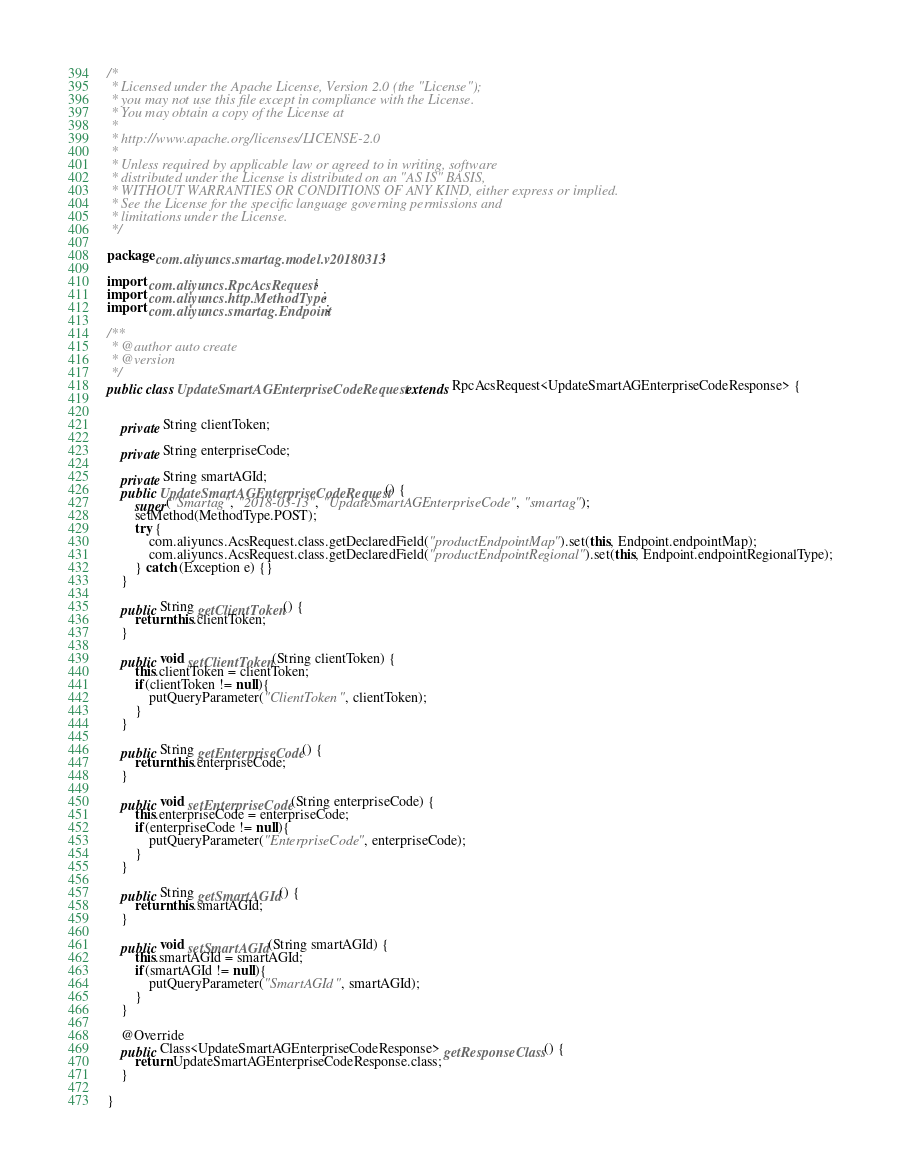<code> <loc_0><loc_0><loc_500><loc_500><_Java_>/*
 * Licensed under the Apache License, Version 2.0 (the "License");
 * you may not use this file except in compliance with the License.
 * You may obtain a copy of the License at
 *
 * http://www.apache.org/licenses/LICENSE-2.0
 *
 * Unless required by applicable law or agreed to in writing, software
 * distributed under the License is distributed on an "AS IS" BASIS,
 * WITHOUT WARRANTIES OR CONDITIONS OF ANY KIND, either express or implied.
 * See the License for the specific language governing permissions and
 * limitations under the License.
 */

package com.aliyuncs.smartag.model.v20180313;

import com.aliyuncs.RpcAcsRequest;
import com.aliyuncs.http.MethodType;
import com.aliyuncs.smartag.Endpoint;

/**
 * @author auto create
 * @version 
 */
public class UpdateSmartAGEnterpriseCodeRequest extends RpcAcsRequest<UpdateSmartAGEnterpriseCodeResponse> {
	   

	private String clientToken;

	private String enterpriseCode;

	private String smartAGId;
	public UpdateSmartAGEnterpriseCodeRequest() {
		super("Smartag", "2018-03-13", "UpdateSmartAGEnterpriseCode", "smartag");
		setMethod(MethodType.POST);
		try {
			com.aliyuncs.AcsRequest.class.getDeclaredField("productEndpointMap").set(this, Endpoint.endpointMap);
			com.aliyuncs.AcsRequest.class.getDeclaredField("productEndpointRegional").set(this, Endpoint.endpointRegionalType);
		} catch (Exception e) {}
	}

	public String getClientToken() {
		return this.clientToken;
	}

	public void setClientToken(String clientToken) {
		this.clientToken = clientToken;
		if(clientToken != null){
			putQueryParameter("ClientToken", clientToken);
		}
	}

	public String getEnterpriseCode() {
		return this.enterpriseCode;
	}

	public void setEnterpriseCode(String enterpriseCode) {
		this.enterpriseCode = enterpriseCode;
		if(enterpriseCode != null){
			putQueryParameter("EnterpriseCode", enterpriseCode);
		}
	}

	public String getSmartAGId() {
		return this.smartAGId;
	}

	public void setSmartAGId(String smartAGId) {
		this.smartAGId = smartAGId;
		if(smartAGId != null){
			putQueryParameter("SmartAGId", smartAGId);
		}
	}

	@Override
	public Class<UpdateSmartAGEnterpriseCodeResponse> getResponseClass() {
		return UpdateSmartAGEnterpriseCodeResponse.class;
	}

}
</code> 